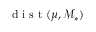Convert formula to latex. <formula><loc_0><loc_0><loc_500><loc_500>d i s t ( \mu , \mathcal { M } _ { * } )</formula> 